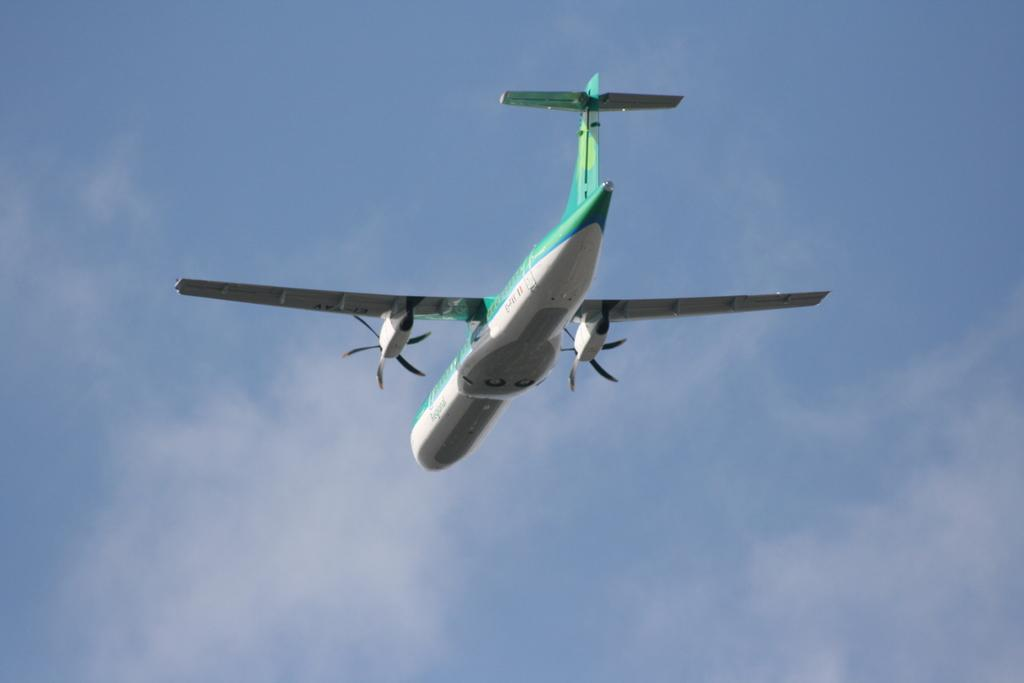What is the main subject of the image? The main subject of the image is an aircraft. Where is the aircraft located in the image? The aircraft is in the sky. What type of battle is taking place in the image? There is no battle present in the image; it features an aircraft in the sky. What hobbies are the passengers of the aircraft engaging in during the flight? The image does not provide information about the passengers or their hobbies. What religious symbols can be seen on the aircraft in the image? There are no religious symbols visible on the aircraft in the image. 